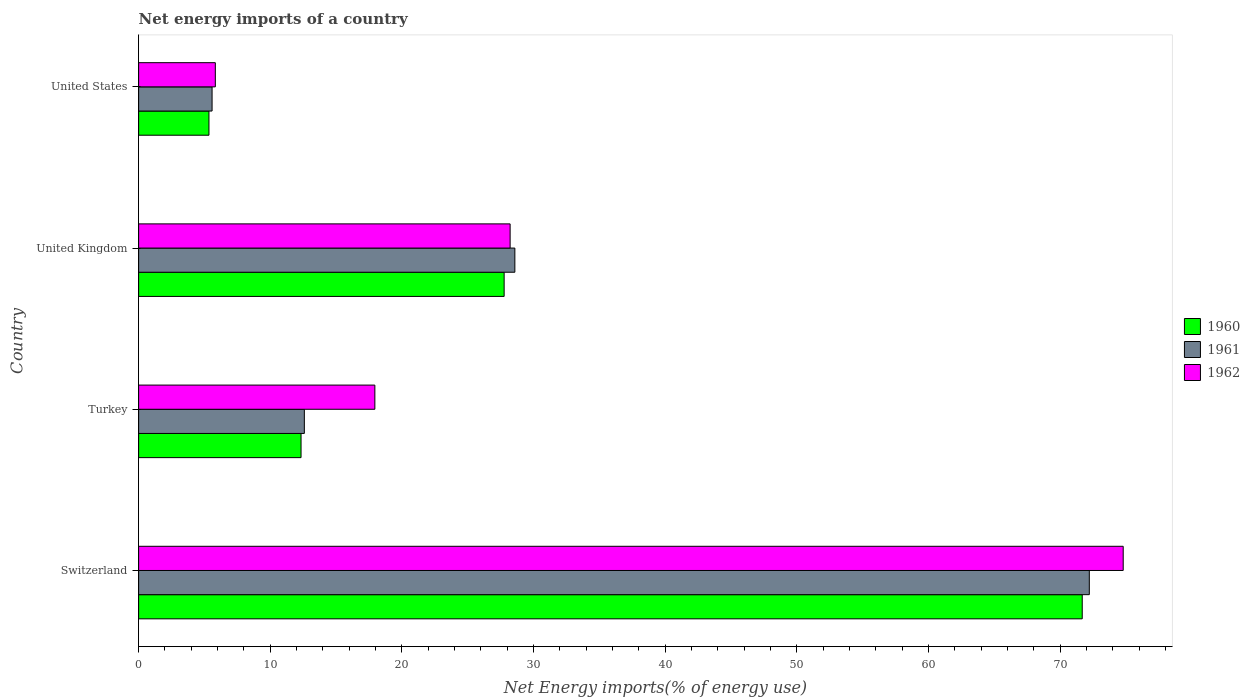Are the number of bars per tick equal to the number of legend labels?
Offer a very short reply. Yes. How many bars are there on the 2nd tick from the top?
Offer a terse response. 3. What is the label of the 3rd group of bars from the top?
Give a very brief answer. Turkey. What is the net energy imports in 1961 in United Kingdom?
Make the answer very short. 28.58. Across all countries, what is the maximum net energy imports in 1961?
Your response must be concise. 72.21. Across all countries, what is the minimum net energy imports in 1962?
Offer a terse response. 5.83. In which country was the net energy imports in 1960 maximum?
Keep it short and to the point. Switzerland. In which country was the net energy imports in 1962 minimum?
Your response must be concise. United States. What is the total net energy imports in 1962 in the graph?
Your answer should be compact. 126.76. What is the difference between the net energy imports in 1960 in Turkey and that in United Kingdom?
Keep it short and to the point. -15.43. What is the difference between the net energy imports in 1960 in United Kingdom and the net energy imports in 1961 in Switzerland?
Offer a very short reply. -44.44. What is the average net energy imports in 1962 per country?
Make the answer very short. 31.69. What is the difference between the net energy imports in 1961 and net energy imports in 1960 in Switzerland?
Ensure brevity in your answer.  0.54. What is the ratio of the net energy imports in 1960 in Switzerland to that in United States?
Your answer should be compact. 13.42. Is the difference between the net energy imports in 1961 in Switzerland and Turkey greater than the difference between the net energy imports in 1960 in Switzerland and Turkey?
Offer a terse response. Yes. What is the difference between the highest and the second highest net energy imports in 1962?
Your answer should be very brief. 46.56. What is the difference between the highest and the lowest net energy imports in 1961?
Your answer should be compact. 66.63. In how many countries, is the net energy imports in 1962 greater than the average net energy imports in 1962 taken over all countries?
Provide a succinct answer. 1. Is it the case that in every country, the sum of the net energy imports in 1962 and net energy imports in 1961 is greater than the net energy imports in 1960?
Provide a succinct answer. Yes. How many bars are there?
Ensure brevity in your answer.  12. How many countries are there in the graph?
Make the answer very short. 4. Are the values on the major ticks of X-axis written in scientific E-notation?
Your answer should be very brief. No. Does the graph contain any zero values?
Offer a very short reply. No. Does the graph contain grids?
Give a very brief answer. No. Where does the legend appear in the graph?
Your response must be concise. Center right. How many legend labels are there?
Keep it short and to the point. 3. How are the legend labels stacked?
Make the answer very short. Vertical. What is the title of the graph?
Provide a short and direct response. Net energy imports of a country. Does "1968" appear as one of the legend labels in the graph?
Give a very brief answer. No. What is the label or title of the X-axis?
Ensure brevity in your answer.  Net Energy imports(% of energy use). What is the Net Energy imports(% of energy use) of 1960 in Switzerland?
Provide a succinct answer. 71.67. What is the Net Energy imports(% of energy use) of 1961 in Switzerland?
Your answer should be very brief. 72.21. What is the Net Energy imports(% of energy use) in 1962 in Switzerland?
Provide a short and direct response. 74.78. What is the Net Energy imports(% of energy use) of 1960 in Turkey?
Provide a short and direct response. 12.34. What is the Net Energy imports(% of energy use) in 1961 in Turkey?
Ensure brevity in your answer.  12.59. What is the Net Energy imports(% of energy use) in 1962 in Turkey?
Give a very brief answer. 17.94. What is the Net Energy imports(% of energy use) in 1960 in United Kingdom?
Your answer should be very brief. 27.76. What is the Net Energy imports(% of energy use) in 1961 in United Kingdom?
Your response must be concise. 28.58. What is the Net Energy imports(% of energy use) of 1962 in United Kingdom?
Offer a terse response. 28.22. What is the Net Energy imports(% of energy use) of 1960 in United States?
Give a very brief answer. 5.34. What is the Net Energy imports(% of energy use) of 1961 in United States?
Your response must be concise. 5.58. What is the Net Energy imports(% of energy use) in 1962 in United States?
Ensure brevity in your answer.  5.83. Across all countries, what is the maximum Net Energy imports(% of energy use) of 1960?
Offer a terse response. 71.67. Across all countries, what is the maximum Net Energy imports(% of energy use) of 1961?
Offer a terse response. 72.21. Across all countries, what is the maximum Net Energy imports(% of energy use) of 1962?
Your response must be concise. 74.78. Across all countries, what is the minimum Net Energy imports(% of energy use) of 1960?
Keep it short and to the point. 5.34. Across all countries, what is the minimum Net Energy imports(% of energy use) of 1961?
Make the answer very short. 5.58. Across all countries, what is the minimum Net Energy imports(% of energy use) of 1962?
Your response must be concise. 5.83. What is the total Net Energy imports(% of energy use) in 1960 in the graph?
Offer a very short reply. 117.11. What is the total Net Energy imports(% of energy use) of 1961 in the graph?
Offer a terse response. 118.95. What is the total Net Energy imports(% of energy use) in 1962 in the graph?
Offer a very short reply. 126.76. What is the difference between the Net Energy imports(% of energy use) of 1960 in Switzerland and that in Turkey?
Ensure brevity in your answer.  59.33. What is the difference between the Net Energy imports(% of energy use) of 1961 in Switzerland and that in Turkey?
Your response must be concise. 59.62. What is the difference between the Net Energy imports(% of energy use) in 1962 in Switzerland and that in Turkey?
Your answer should be compact. 56.84. What is the difference between the Net Energy imports(% of energy use) in 1960 in Switzerland and that in United Kingdom?
Offer a very short reply. 43.91. What is the difference between the Net Energy imports(% of energy use) in 1961 in Switzerland and that in United Kingdom?
Keep it short and to the point. 43.63. What is the difference between the Net Energy imports(% of energy use) in 1962 in Switzerland and that in United Kingdom?
Give a very brief answer. 46.56. What is the difference between the Net Energy imports(% of energy use) in 1960 in Switzerland and that in United States?
Your answer should be compact. 66.33. What is the difference between the Net Energy imports(% of energy use) of 1961 in Switzerland and that in United States?
Ensure brevity in your answer.  66.63. What is the difference between the Net Energy imports(% of energy use) in 1962 in Switzerland and that in United States?
Make the answer very short. 68.95. What is the difference between the Net Energy imports(% of energy use) in 1960 in Turkey and that in United Kingdom?
Keep it short and to the point. -15.43. What is the difference between the Net Energy imports(% of energy use) of 1961 in Turkey and that in United Kingdom?
Offer a very short reply. -15.99. What is the difference between the Net Energy imports(% of energy use) in 1962 in Turkey and that in United Kingdom?
Offer a very short reply. -10.27. What is the difference between the Net Energy imports(% of energy use) of 1960 in Turkey and that in United States?
Your answer should be compact. 6.99. What is the difference between the Net Energy imports(% of energy use) of 1961 in Turkey and that in United States?
Provide a succinct answer. 7.01. What is the difference between the Net Energy imports(% of energy use) in 1962 in Turkey and that in United States?
Give a very brief answer. 12.12. What is the difference between the Net Energy imports(% of energy use) in 1960 in United Kingdom and that in United States?
Provide a short and direct response. 22.42. What is the difference between the Net Energy imports(% of energy use) in 1961 in United Kingdom and that in United States?
Keep it short and to the point. 23. What is the difference between the Net Energy imports(% of energy use) in 1962 in United Kingdom and that in United States?
Offer a very short reply. 22.39. What is the difference between the Net Energy imports(% of energy use) in 1960 in Switzerland and the Net Energy imports(% of energy use) in 1961 in Turkey?
Provide a succinct answer. 59.08. What is the difference between the Net Energy imports(% of energy use) of 1960 in Switzerland and the Net Energy imports(% of energy use) of 1962 in Turkey?
Provide a short and direct response. 53.73. What is the difference between the Net Energy imports(% of energy use) of 1961 in Switzerland and the Net Energy imports(% of energy use) of 1962 in Turkey?
Make the answer very short. 54.26. What is the difference between the Net Energy imports(% of energy use) of 1960 in Switzerland and the Net Energy imports(% of energy use) of 1961 in United Kingdom?
Keep it short and to the point. 43.09. What is the difference between the Net Energy imports(% of energy use) in 1960 in Switzerland and the Net Energy imports(% of energy use) in 1962 in United Kingdom?
Offer a terse response. 43.45. What is the difference between the Net Energy imports(% of energy use) in 1961 in Switzerland and the Net Energy imports(% of energy use) in 1962 in United Kingdom?
Provide a succinct answer. 43.99. What is the difference between the Net Energy imports(% of energy use) in 1960 in Switzerland and the Net Energy imports(% of energy use) in 1961 in United States?
Ensure brevity in your answer.  66.09. What is the difference between the Net Energy imports(% of energy use) of 1960 in Switzerland and the Net Energy imports(% of energy use) of 1962 in United States?
Your answer should be compact. 65.84. What is the difference between the Net Energy imports(% of energy use) in 1961 in Switzerland and the Net Energy imports(% of energy use) in 1962 in United States?
Offer a terse response. 66.38. What is the difference between the Net Energy imports(% of energy use) of 1960 in Turkey and the Net Energy imports(% of energy use) of 1961 in United Kingdom?
Provide a succinct answer. -16.24. What is the difference between the Net Energy imports(% of energy use) of 1960 in Turkey and the Net Energy imports(% of energy use) of 1962 in United Kingdom?
Your answer should be very brief. -15.88. What is the difference between the Net Energy imports(% of energy use) in 1961 in Turkey and the Net Energy imports(% of energy use) in 1962 in United Kingdom?
Keep it short and to the point. -15.63. What is the difference between the Net Energy imports(% of energy use) of 1960 in Turkey and the Net Energy imports(% of energy use) of 1961 in United States?
Offer a very short reply. 6.76. What is the difference between the Net Energy imports(% of energy use) of 1960 in Turkey and the Net Energy imports(% of energy use) of 1962 in United States?
Your answer should be compact. 6.51. What is the difference between the Net Energy imports(% of energy use) of 1961 in Turkey and the Net Energy imports(% of energy use) of 1962 in United States?
Offer a very short reply. 6.76. What is the difference between the Net Energy imports(% of energy use) in 1960 in United Kingdom and the Net Energy imports(% of energy use) in 1961 in United States?
Offer a very short reply. 22.18. What is the difference between the Net Energy imports(% of energy use) of 1960 in United Kingdom and the Net Energy imports(% of energy use) of 1962 in United States?
Provide a short and direct response. 21.94. What is the difference between the Net Energy imports(% of energy use) in 1961 in United Kingdom and the Net Energy imports(% of energy use) in 1962 in United States?
Provide a short and direct response. 22.75. What is the average Net Energy imports(% of energy use) of 1960 per country?
Provide a succinct answer. 29.28. What is the average Net Energy imports(% of energy use) in 1961 per country?
Ensure brevity in your answer.  29.74. What is the average Net Energy imports(% of energy use) of 1962 per country?
Make the answer very short. 31.69. What is the difference between the Net Energy imports(% of energy use) of 1960 and Net Energy imports(% of energy use) of 1961 in Switzerland?
Offer a terse response. -0.54. What is the difference between the Net Energy imports(% of energy use) in 1960 and Net Energy imports(% of energy use) in 1962 in Switzerland?
Offer a very short reply. -3.11. What is the difference between the Net Energy imports(% of energy use) in 1961 and Net Energy imports(% of energy use) in 1962 in Switzerland?
Ensure brevity in your answer.  -2.57. What is the difference between the Net Energy imports(% of energy use) of 1960 and Net Energy imports(% of energy use) of 1961 in Turkey?
Your answer should be very brief. -0.25. What is the difference between the Net Energy imports(% of energy use) of 1960 and Net Energy imports(% of energy use) of 1962 in Turkey?
Offer a terse response. -5.61. What is the difference between the Net Energy imports(% of energy use) in 1961 and Net Energy imports(% of energy use) in 1962 in Turkey?
Keep it short and to the point. -5.36. What is the difference between the Net Energy imports(% of energy use) of 1960 and Net Energy imports(% of energy use) of 1961 in United Kingdom?
Make the answer very short. -0.81. What is the difference between the Net Energy imports(% of energy use) in 1960 and Net Energy imports(% of energy use) in 1962 in United Kingdom?
Offer a very short reply. -0.45. What is the difference between the Net Energy imports(% of energy use) in 1961 and Net Energy imports(% of energy use) in 1962 in United Kingdom?
Provide a short and direct response. 0.36. What is the difference between the Net Energy imports(% of energy use) in 1960 and Net Energy imports(% of energy use) in 1961 in United States?
Make the answer very short. -0.24. What is the difference between the Net Energy imports(% of energy use) in 1960 and Net Energy imports(% of energy use) in 1962 in United States?
Give a very brief answer. -0.49. What is the difference between the Net Energy imports(% of energy use) in 1961 and Net Energy imports(% of energy use) in 1962 in United States?
Give a very brief answer. -0.25. What is the ratio of the Net Energy imports(% of energy use) of 1960 in Switzerland to that in Turkey?
Your answer should be very brief. 5.81. What is the ratio of the Net Energy imports(% of energy use) of 1961 in Switzerland to that in Turkey?
Give a very brief answer. 5.74. What is the ratio of the Net Energy imports(% of energy use) of 1962 in Switzerland to that in Turkey?
Provide a succinct answer. 4.17. What is the ratio of the Net Energy imports(% of energy use) in 1960 in Switzerland to that in United Kingdom?
Offer a very short reply. 2.58. What is the ratio of the Net Energy imports(% of energy use) in 1961 in Switzerland to that in United Kingdom?
Provide a succinct answer. 2.53. What is the ratio of the Net Energy imports(% of energy use) of 1962 in Switzerland to that in United Kingdom?
Make the answer very short. 2.65. What is the ratio of the Net Energy imports(% of energy use) of 1960 in Switzerland to that in United States?
Your answer should be very brief. 13.42. What is the ratio of the Net Energy imports(% of energy use) in 1961 in Switzerland to that in United States?
Provide a succinct answer. 12.94. What is the ratio of the Net Energy imports(% of energy use) of 1962 in Switzerland to that in United States?
Your answer should be very brief. 12.84. What is the ratio of the Net Energy imports(% of energy use) of 1960 in Turkey to that in United Kingdom?
Your answer should be very brief. 0.44. What is the ratio of the Net Energy imports(% of energy use) of 1961 in Turkey to that in United Kingdom?
Offer a very short reply. 0.44. What is the ratio of the Net Energy imports(% of energy use) of 1962 in Turkey to that in United Kingdom?
Make the answer very short. 0.64. What is the ratio of the Net Energy imports(% of energy use) in 1960 in Turkey to that in United States?
Offer a very short reply. 2.31. What is the ratio of the Net Energy imports(% of energy use) of 1961 in Turkey to that in United States?
Your response must be concise. 2.26. What is the ratio of the Net Energy imports(% of energy use) in 1962 in Turkey to that in United States?
Your response must be concise. 3.08. What is the ratio of the Net Energy imports(% of energy use) in 1960 in United Kingdom to that in United States?
Your answer should be very brief. 5.2. What is the ratio of the Net Energy imports(% of energy use) of 1961 in United Kingdom to that in United States?
Ensure brevity in your answer.  5.12. What is the ratio of the Net Energy imports(% of energy use) of 1962 in United Kingdom to that in United States?
Make the answer very short. 4.84. What is the difference between the highest and the second highest Net Energy imports(% of energy use) of 1960?
Keep it short and to the point. 43.91. What is the difference between the highest and the second highest Net Energy imports(% of energy use) of 1961?
Keep it short and to the point. 43.63. What is the difference between the highest and the second highest Net Energy imports(% of energy use) in 1962?
Provide a succinct answer. 46.56. What is the difference between the highest and the lowest Net Energy imports(% of energy use) of 1960?
Offer a terse response. 66.33. What is the difference between the highest and the lowest Net Energy imports(% of energy use) of 1961?
Ensure brevity in your answer.  66.63. What is the difference between the highest and the lowest Net Energy imports(% of energy use) of 1962?
Your response must be concise. 68.95. 